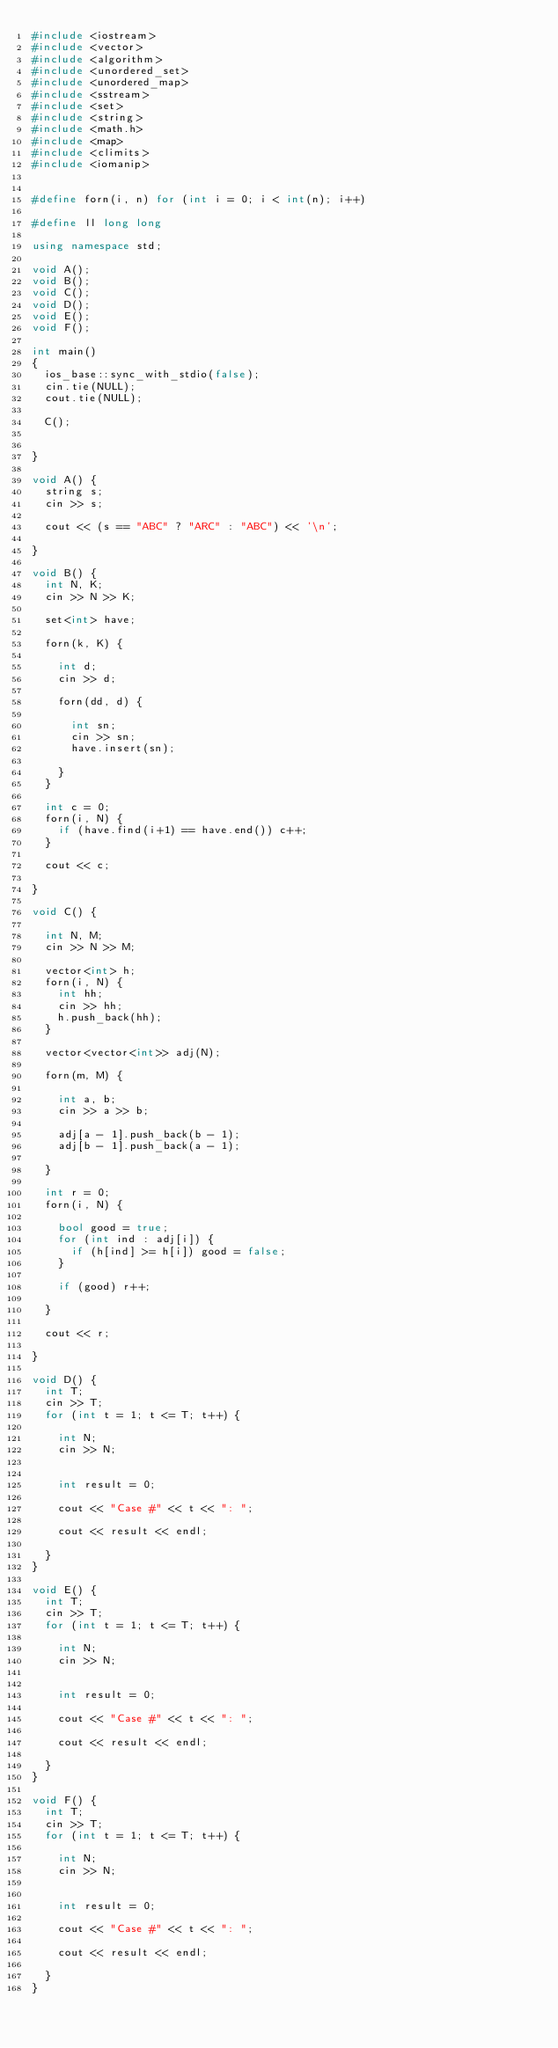Convert code to text. <code><loc_0><loc_0><loc_500><loc_500><_C++_>#include <iostream>
#include <vector>
#include <algorithm>
#include <unordered_set>
#include <unordered_map>
#include <sstream>
#include <set>
#include <string>
#include <math.h>
#include <map>
#include <climits>
#include <iomanip>


#define forn(i, n) for (int i = 0; i < int(n); i++)

#define ll long long

using namespace std;

void A();
void B();
void C();
void D();
void E();
void F();

int main()
{
	ios_base::sync_with_stdio(false);
	cin.tie(NULL);
	cout.tie(NULL);

	C();


}

void A() {
	string s;
	cin >> s;

	cout << (s == "ABC" ? "ARC" : "ABC") << '\n';

}

void B() {
	int N, K;
	cin >> N >> K;

	set<int> have;

	forn(k, K) {

		int d;
		cin >> d;

		forn(dd, d) {

			int sn;
			cin >> sn;
			have.insert(sn);

		}
	}

	int c = 0;
	forn(i, N) {
		if (have.find(i+1) == have.end()) c++;
	}

	cout << c;

}

void C() {
	
	int N, M;
	cin >> N >> M;

	vector<int> h;
	forn(i, N) {
		int hh;
		cin >> hh;
		h.push_back(hh);
	}

	vector<vector<int>> adj(N);

	forn(m, M) {

		int a, b;
		cin >> a >> b;

		adj[a - 1].push_back(b - 1);
		adj[b - 1].push_back(a - 1);

	}
	
	int r = 0;
	forn(i, N) {

		bool good = true;
		for (int ind : adj[i]) {
			if (h[ind] >= h[i]) good = false;
		}

		if (good) r++;

	}

	cout << r;

}

void D() {
	int T;
	cin >> T;
	for (int t = 1; t <= T; t++) {

		int N;
		cin >> N;


		int result = 0;

		cout << "Case #" << t << ": ";

		cout << result << endl;

	}
}

void E() {
	int T;
	cin >> T;
	for (int t = 1; t <= T; t++) {

		int N;
		cin >> N;


		int result = 0;

		cout << "Case #" << t << ": ";

		cout << result << endl;

	}
}

void F() {
	int T;
	cin >> T;
	for (int t = 1; t <= T; t++) {

		int N;
		cin >> N;


		int result = 0;

		cout << "Case #" << t << ": ";

		cout << result << endl;

	}
}

</code> 